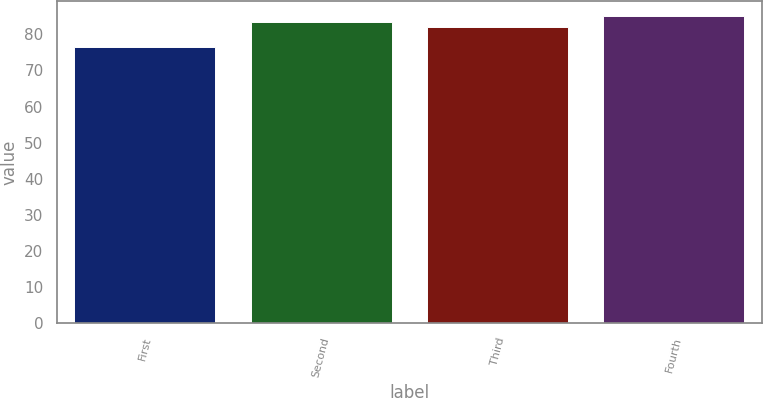Convert chart. <chart><loc_0><loc_0><loc_500><loc_500><bar_chart><fcel>First<fcel>Second<fcel>Third<fcel>Fourth<nl><fcel>76.5<fcel>83.43<fcel>82.15<fcel>84.99<nl></chart> 